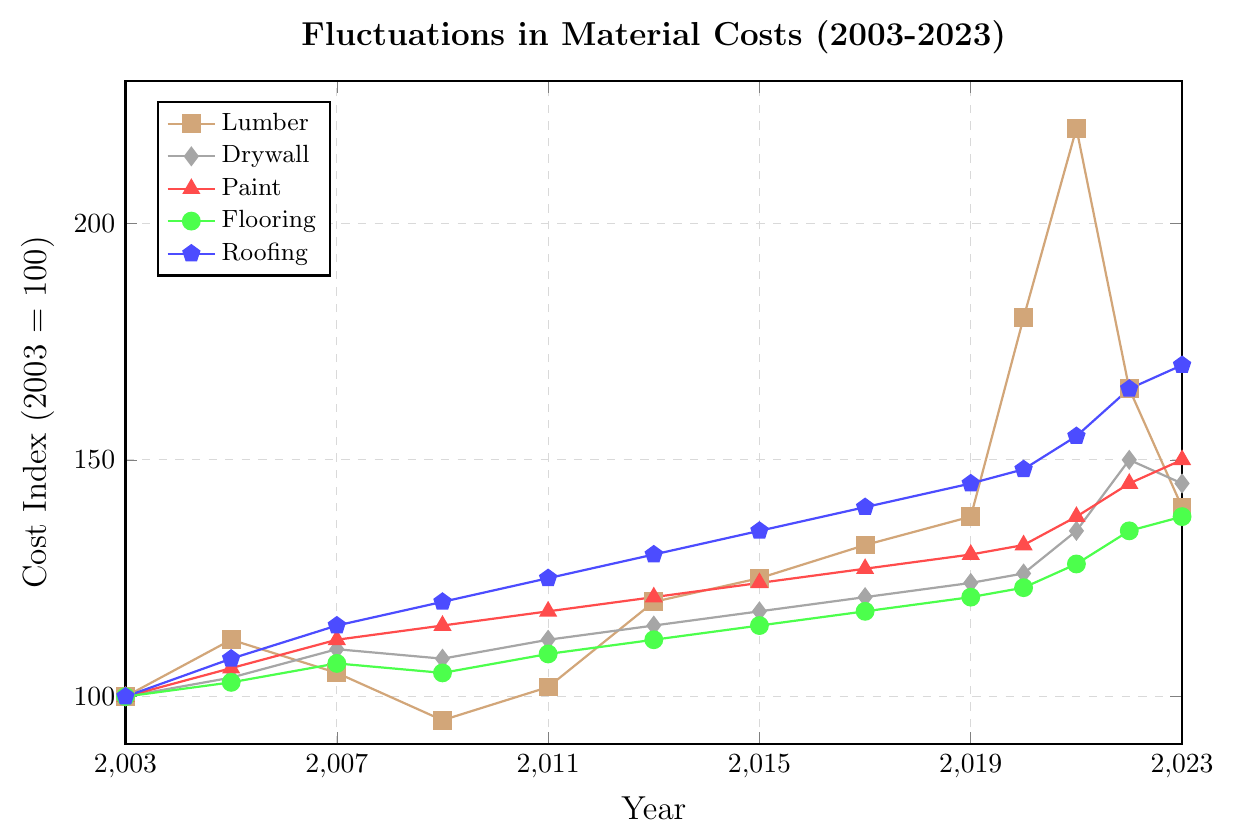What was the cost index for lumber in 2021? Find the lumber cost index on the y-axis corresponding to the year 2021 on the x-axis.
Answer: 220 Which material had the highest cost index in 2023? Compare the cost index for all materials in the year 2023 and find the highest one. Lumber: 140, Drywall: 145, Paint: 150, Flooring: 138, Roofing: 170. Roofing has the highest index.
Answer: Roofing Did the cost index for paint ever exceed 145? Observe the cost index trend for paint (red line) and check if it ever goes above 145. The cost index for paint in 2022 was 145, and in 2023 it was 150.
Answer: Yes How did the cost of drywall change from 2020 to 2022? Find the cost indices for drywall in 2020 and 2022, then calculate the difference. Drywall cost index in 2020 was 126, and in 2022 it was 150. The change is 150 - 126 = 24.
Answer: Increased by 24 Compare the trends of lumber and flooring costs between 2019 and 2021. Analyze the costs for lumber and flooring from 2019 to 2021. Lumber increased from 138 in 2019 to 220 in 2021, while flooring increased from 121 to 128. Both increased, with lumber having a steeper rise.
Answer: Both increased, with lumber rising more steeply What was the average cost index of roofing from 2017 to 2023? Find the roofing cost indices from 2017 to 2023 and calculate their average. 2017: 140, 2019: 145, 2020: 148, 2021: 155, 2022: 165, 2023: 170. Sum is 923, average is 923/6 = 153.833.
Answer: 153.833 Which material had the lowest increase in cost from 2003 to 2023? Calculate the increase for all materials: Lumber: 140-100=40, Drywall: 145-100=45, Paint: 150-100=50, Flooring: 138-100=38, Roofing: 170-100=70. Flooring had the lowest increase.
Answer: Flooring Is there any year where all materials have increased in cost compared to 2003? Compare the cost indices of all materials for each year with their respective indices from 2003. For example, in 2005: Lumber, Drywall, Paint, Flooring, and Roofing all have increased compared to 2003.
Answer: 2005 How did the cost of lumber fluctuate between 2005 and 2023? Track the cost indices for lumber from 2005 to 2023: 2005 (112), 2007 (105), 2009 (95), 2011 (102), 2013 (120), 2015 (125), 2017 (132), 2019 (138), 2020 (180), 2021 (220), 2022 (165), 2023 (140). It fluctuated with noticeable peaks in 2020 and 2021.
Answer: Fluctuated with peaks in 2020 and 2021 